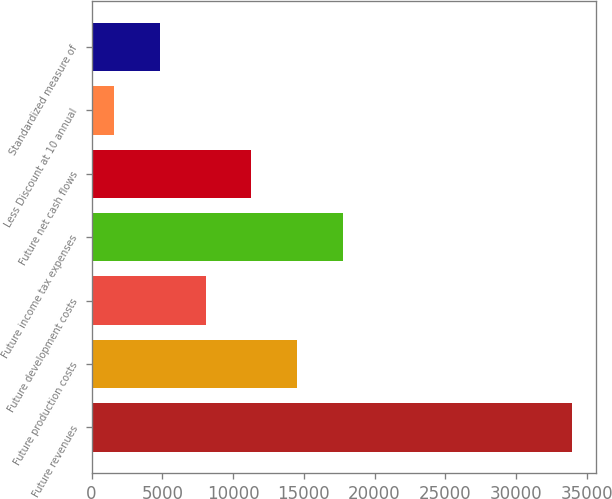Convert chart. <chart><loc_0><loc_0><loc_500><loc_500><bar_chart><fcel>Future revenues<fcel>Future production costs<fcel>Future development costs<fcel>Future income tax expenses<fcel>Future net cash flows<fcel>Less Discount at 10 annual<fcel>Standardized measure of<nl><fcel>33974<fcel>14541.8<fcel>8064.4<fcel>17780.5<fcel>11303.1<fcel>1587<fcel>4825.7<nl></chart> 